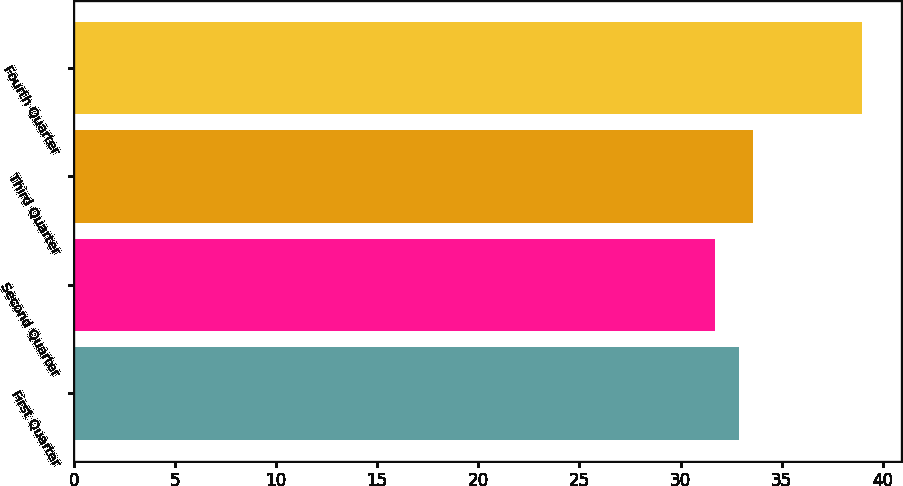Convert chart. <chart><loc_0><loc_0><loc_500><loc_500><bar_chart><fcel>First Quarter<fcel>Second Quarter<fcel>Third Quarter<fcel>Fourth Quarter<nl><fcel>32.88<fcel>31.72<fcel>33.6<fcel>38.95<nl></chart> 